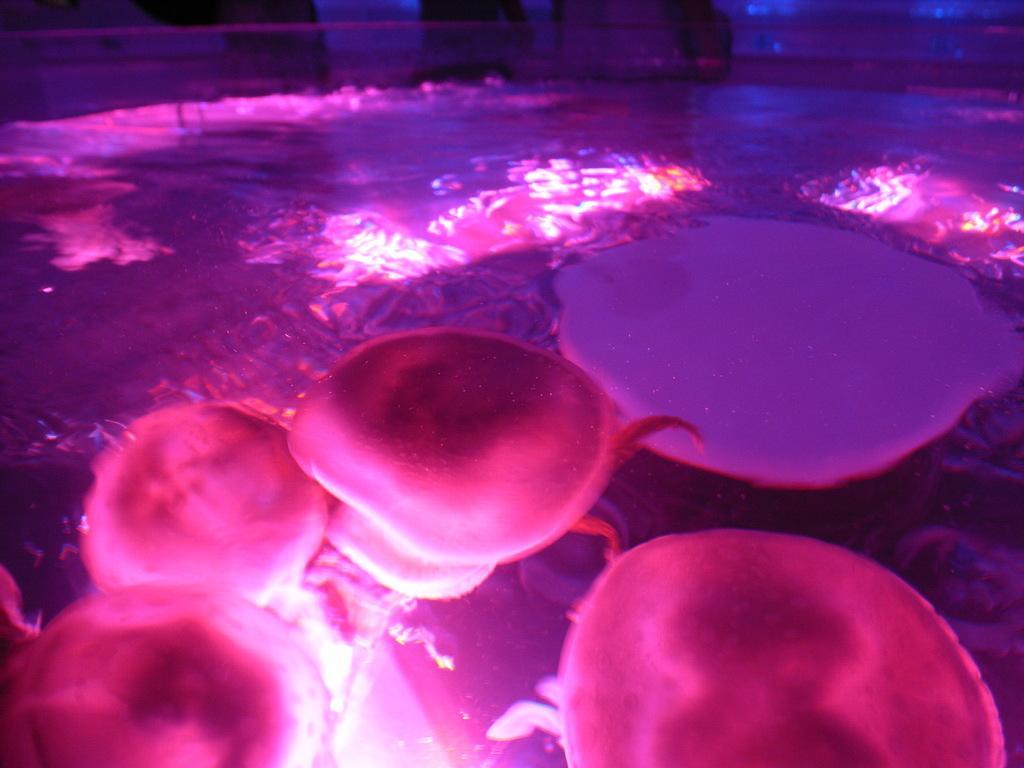Please provide a concise description of this image. In this picture we can see the water animals in the water. 